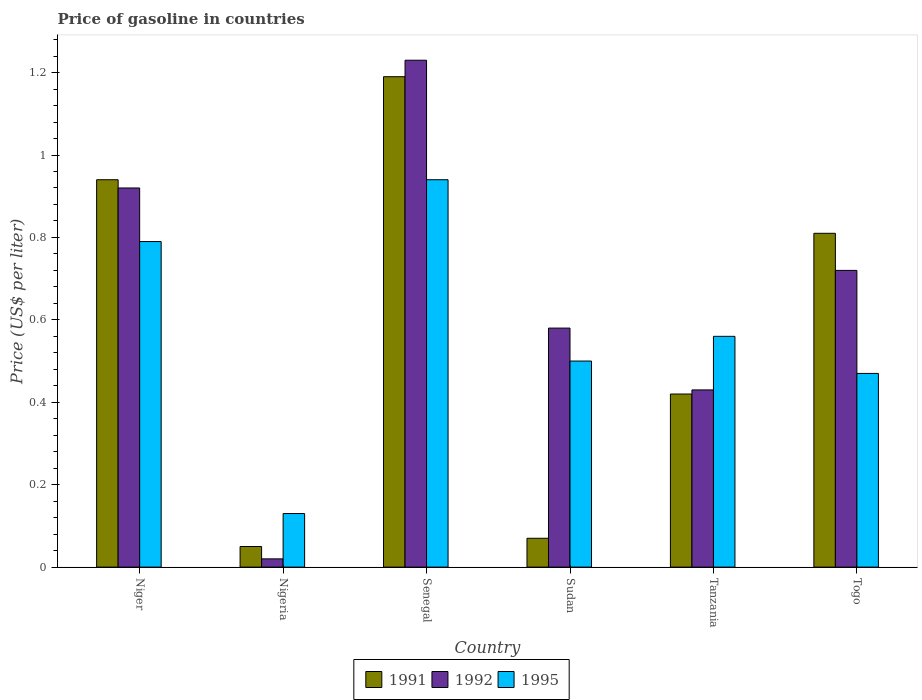How many different coloured bars are there?
Make the answer very short. 3. How many groups of bars are there?
Your response must be concise. 6. Are the number of bars per tick equal to the number of legend labels?
Make the answer very short. Yes. How many bars are there on the 2nd tick from the left?
Offer a very short reply. 3. How many bars are there on the 4th tick from the right?
Your response must be concise. 3. What is the label of the 4th group of bars from the left?
Your answer should be compact. Sudan. What is the price of gasoline in 1991 in Senegal?
Offer a very short reply. 1.19. Across all countries, what is the minimum price of gasoline in 1991?
Keep it short and to the point. 0.05. In which country was the price of gasoline in 1991 maximum?
Your response must be concise. Senegal. In which country was the price of gasoline in 1991 minimum?
Provide a short and direct response. Nigeria. What is the total price of gasoline in 1992 in the graph?
Offer a terse response. 3.9. What is the difference between the price of gasoline in 1995 in Niger and that in Tanzania?
Give a very brief answer. 0.23. What is the difference between the price of gasoline in 1992 in Tanzania and the price of gasoline in 1995 in Senegal?
Make the answer very short. -0.51. What is the average price of gasoline in 1992 per country?
Your answer should be very brief. 0.65. What is the difference between the price of gasoline of/in 1992 and price of gasoline of/in 1991 in Togo?
Give a very brief answer. -0.09. What is the ratio of the price of gasoline in 1991 in Nigeria to that in Sudan?
Make the answer very short. 0.71. What is the difference between the highest and the second highest price of gasoline in 1992?
Provide a succinct answer. -0.31. What is the difference between the highest and the lowest price of gasoline in 1992?
Ensure brevity in your answer.  1.21. In how many countries, is the price of gasoline in 1995 greater than the average price of gasoline in 1995 taken over all countries?
Keep it short and to the point. 2. What does the 3rd bar from the right in Nigeria represents?
Give a very brief answer. 1991. How many bars are there?
Your answer should be compact. 18. How many countries are there in the graph?
Give a very brief answer. 6. What is the difference between two consecutive major ticks on the Y-axis?
Provide a succinct answer. 0.2. Are the values on the major ticks of Y-axis written in scientific E-notation?
Ensure brevity in your answer.  No. What is the title of the graph?
Make the answer very short. Price of gasoline in countries. What is the label or title of the Y-axis?
Make the answer very short. Price (US$ per liter). What is the Price (US$ per liter) of 1991 in Niger?
Offer a very short reply. 0.94. What is the Price (US$ per liter) of 1992 in Niger?
Provide a short and direct response. 0.92. What is the Price (US$ per liter) of 1995 in Niger?
Keep it short and to the point. 0.79. What is the Price (US$ per liter) in 1991 in Nigeria?
Offer a terse response. 0.05. What is the Price (US$ per liter) of 1995 in Nigeria?
Ensure brevity in your answer.  0.13. What is the Price (US$ per liter) in 1991 in Senegal?
Your response must be concise. 1.19. What is the Price (US$ per liter) in 1992 in Senegal?
Your answer should be very brief. 1.23. What is the Price (US$ per liter) of 1995 in Senegal?
Your answer should be very brief. 0.94. What is the Price (US$ per liter) of 1991 in Sudan?
Keep it short and to the point. 0.07. What is the Price (US$ per liter) in 1992 in Sudan?
Offer a very short reply. 0.58. What is the Price (US$ per liter) in 1991 in Tanzania?
Provide a short and direct response. 0.42. What is the Price (US$ per liter) of 1992 in Tanzania?
Give a very brief answer. 0.43. What is the Price (US$ per liter) of 1995 in Tanzania?
Provide a succinct answer. 0.56. What is the Price (US$ per liter) in 1991 in Togo?
Your answer should be very brief. 0.81. What is the Price (US$ per liter) in 1992 in Togo?
Your response must be concise. 0.72. What is the Price (US$ per liter) of 1995 in Togo?
Your answer should be very brief. 0.47. Across all countries, what is the maximum Price (US$ per liter) of 1991?
Ensure brevity in your answer.  1.19. Across all countries, what is the maximum Price (US$ per liter) of 1992?
Your response must be concise. 1.23. Across all countries, what is the maximum Price (US$ per liter) in 1995?
Your response must be concise. 0.94. Across all countries, what is the minimum Price (US$ per liter) of 1991?
Ensure brevity in your answer.  0.05. Across all countries, what is the minimum Price (US$ per liter) in 1995?
Offer a terse response. 0.13. What is the total Price (US$ per liter) of 1991 in the graph?
Make the answer very short. 3.48. What is the total Price (US$ per liter) of 1992 in the graph?
Your answer should be compact. 3.9. What is the total Price (US$ per liter) in 1995 in the graph?
Offer a terse response. 3.39. What is the difference between the Price (US$ per liter) in 1991 in Niger and that in Nigeria?
Offer a very short reply. 0.89. What is the difference between the Price (US$ per liter) of 1992 in Niger and that in Nigeria?
Offer a terse response. 0.9. What is the difference between the Price (US$ per liter) of 1995 in Niger and that in Nigeria?
Make the answer very short. 0.66. What is the difference between the Price (US$ per liter) in 1992 in Niger and that in Senegal?
Provide a short and direct response. -0.31. What is the difference between the Price (US$ per liter) in 1995 in Niger and that in Senegal?
Give a very brief answer. -0.15. What is the difference between the Price (US$ per liter) in 1991 in Niger and that in Sudan?
Your answer should be compact. 0.87. What is the difference between the Price (US$ per liter) of 1992 in Niger and that in Sudan?
Provide a short and direct response. 0.34. What is the difference between the Price (US$ per liter) of 1995 in Niger and that in Sudan?
Your answer should be compact. 0.29. What is the difference between the Price (US$ per liter) of 1991 in Niger and that in Tanzania?
Your answer should be very brief. 0.52. What is the difference between the Price (US$ per liter) in 1992 in Niger and that in Tanzania?
Your answer should be compact. 0.49. What is the difference between the Price (US$ per liter) in 1995 in Niger and that in Tanzania?
Your answer should be very brief. 0.23. What is the difference between the Price (US$ per liter) in 1991 in Niger and that in Togo?
Offer a terse response. 0.13. What is the difference between the Price (US$ per liter) of 1992 in Niger and that in Togo?
Your response must be concise. 0.2. What is the difference between the Price (US$ per liter) of 1995 in Niger and that in Togo?
Make the answer very short. 0.32. What is the difference between the Price (US$ per liter) in 1991 in Nigeria and that in Senegal?
Offer a terse response. -1.14. What is the difference between the Price (US$ per liter) in 1992 in Nigeria and that in Senegal?
Keep it short and to the point. -1.21. What is the difference between the Price (US$ per liter) of 1995 in Nigeria and that in Senegal?
Provide a succinct answer. -0.81. What is the difference between the Price (US$ per liter) of 1991 in Nigeria and that in Sudan?
Your answer should be compact. -0.02. What is the difference between the Price (US$ per liter) in 1992 in Nigeria and that in Sudan?
Provide a succinct answer. -0.56. What is the difference between the Price (US$ per liter) of 1995 in Nigeria and that in Sudan?
Give a very brief answer. -0.37. What is the difference between the Price (US$ per liter) of 1991 in Nigeria and that in Tanzania?
Ensure brevity in your answer.  -0.37. What is the difference between the Price (US$ per liter) of 1992 in Nigeria and that in Tanzania?
Offer a terse response. -0.41. What is the difference between the Price (US$ per liter) of 1995 in Nigeria and that in Tanzania?
Keep it short and to the point. -0.43. What is the difference between the Price (US$ per liter) in 1991 in Nigeria and that in Togo?
Give a very brief answer. -0.76. What is the difference between the Price (US$ per liter) in 1992 in Nigeria and that in Togo?
Give a very brief answer. -0.7. What is the difference between the Price (US$ per liter) in 1995 in Nigeria and that in Togo?
Your answer should be compact. -0.34. What is the difference between the Price (US$ per liter) in 1991 in Senegal and that in Sudan?
Your response must be concise. 1.12. What is the difference between the Price (US$ per liter) of 1992 in Senegal and that in Sudan?
Provide a succinct answer. 0.65. What is the difference between the Price (US$ per liter) of 1995 in Senegal and that in Sudan?
Give a very brief answer. 0.44. What is the difference between the Price (US$ per liter) in 1991 in Senegal and that in Tanzania?
Your answer should be very brief. 0.77. What is the difference between the Price (US$ per liter) of 1995 in Senegal and that in Tanzania?
Provide a short and direct response. 0.38. What is the difference between the Price (US$ per liter) in 1991 in Senegal and that in Togo?
Keep it short and to the point. 0.38. What is the difference between the Price (US$ per liter) in 1992 in Senegal and that in Togo?
Your answer should be compact. 0.51. What is the difference between the Price (US$ per liter) in 1995 in Senegal and that in Togo?
Provide a short and direct response. 0.47. What is the difference between the Price (US$ per liter) of 1991 in Sudan and that in Tanzania?
Offer a terse response. -0.35. What is the difference between the Price (US$ per liter) of 1995 in Sudan and that in Tanzania?
Provide a succinct answer. -0.06. What is the difference between the Price (US$ per liter) of 1991 in Sudan and that in Togo?
Ensure brevity in your answer.  -0.74. What is the difference between the Price (US$ per liter) in 1992 in Sudan and that in Togo?
Make the answer very short. -0.14. What is the difference between the Price (US$ per liter) of 1991 in Tanzania and that in Togo?
Provide a succinct answer. -0.39. What is the difference between the Price (US$ per liter) of 1992 in Tanzania and that in Togo?
Give a very brief answer. -0.29. What is the difference between the Price (US$ per liter) of 1995 in Tanzania and that in Togo?
Give a very brief answer. 0.09. What is the difference between the Price (US$ per liter) of 1991 in Niger and the Price (US$ per liter) of 1995 in Nigeria?
Give a very brief answer. 0.81. What is the difference between the Price (US$ per liter) in 1992 in Niger and the Price (US$ per liter) in 1995 in Nigeria?
Offer a terse response. 0.79. What is the difference between the Price (US$ per liter) of 1991 in Niger and the Price (US$ per liter) of 1992 in Senegal?
Offer a terse response. -0.29. What is the difference between the Price (US$ per liter) in 1991 in Niger and the Price (US$ per liter) in 1995 in Senegal?
Make the answer very short. 0. What is the difference between the Price (US$ per liter) in 1992 in Niger and the Price (US$ per liter) in 1995 in Senegal?
Make the answer very short. -0.02. What is the difference between the Price (US$ per liter) of 1991 in Niger and the Price (US$ per liter) of 1992 in Sudan?
Offer a terse response. 0.36. What is the difference between the Price (US$ per liter) in 1991 in Niger and the Price (US$ per liter) in 1995 in Sudan?
Offer a terse response. 0.44. What is the difference between the Price (US$ per liter) of 1992 in Niger and the Price (US$ per liter) of 1995 in Sudan?
Give a very brief answer. 0.42. What is the difference between the Price (US$ per liter) of 1991 in Niger and the Price (US$ per liter) of 1992 in Tanzania?
Offer a terse response. 0.51. What is the difference between the Price (US$ per liter) in 1991 in Niger and the Price (US$ per liter) in 1995 in Tanzania?
Provide a short and direct response. 0.38. What is the difference between the Price (US$ per liter) of 1992 in Niger and the Price (US$ per liter) of 1995 in Tanzania?
Give a very brief answer. 0.36. What is the difference between the Price (US$ per liter) of 1991 in Niger and the Price (US$ per liter) of 1992 in Togo?
Your answer should be very brief. 0.22. What is the difference between the Price (US$ per liter) of 1991 in Niger and the Price (US$ per liter) of 1995 in Togo?
Your answer should be compact. 0.47. What is the difference between the Price (US$ per liter) of 1992 in Niger and the Price (US$ per liter) of 1995 in Togo?
Your answer should be compact. 0.45. What is the difference between the Price (US$ per liter) in 1991 in Nigeria and the Price (US$ per liter) in 1992 in Senegal?
Make the answer very short. -1.18. What is the difference between the Price (US$ per liter) of 1991 in Nigeria and the Price (US$ per liter) of 1995 in Senegal?
Your response must be concise. -0.89. What is the difference between the Price (US$ per liter) in 1992 in Nigeria and the Price (US$ per liter) in 1995 in Senegal?
Provide a succinct answer. -0.92. What is the difference between the Price (US$ per liter) in 1991 in Nigeria and the Price (US$ per liter) in 1992 in Sudan?
Keep it short and to the point. -0.53. What is the difference between the Price (US$ per liter) in 1991 in Nigeria and the Price (US$ per liter) in 1995 in Sudan?
Your answer should be compact. -0.45. What is the difference between the Price (US$ per liter) in 1992 in Nigeria and the Price (US$ per liter) in 1995 in Sudan?
Give a very brief answer. -0.48. What is the difference between the Price (US$ per liter) of 1991 in Nigeria and the Price (US$ per liter) of 1992 in Tanzania?
Your response must be concise. -0.38. What is the difference between the Price (US$ per liter) in 1991 in Nigeria and the Price (US$ per liter) in 1995 in Tanzania?
Ensure brevity in your answer.  -0.51. What is the difference between the Price (US$ per liter) in 1992 in Nigeria and the Price (US$ per liter) in 1995 in Tanzania?
Your answer should be compact. -0.54. What is the difference between the Price (US$ per liter) of 1991 in Nigeria and the Price (US$ per liter) of 1992 in Togo?
Make the answer very short. -0.67. What is the difference between the Price (US$ per liter) of 1991 in Nigeria and the Price (US$ per liter) of 1995 in Togo?
Provide a short and direct response. -0.42. What is the difference between the Price (US$ per liter) of 1992 in Nigeria and the Price (US$ per liter) of 1995 in Togo?
Provide a short and direct response. -0.45. What is the difference between the Price (US$ per liter) of 1991 in Senegal and the Price (US$ per liter) of 1992 in Sudan?
Give a very brief answer. 0.61. What is the difference between the Price (US$ per liter) of 1991 in Senegal and the Price (US$ per liter) of 1995 in Sudan?
Ensure brevity in your answer.  0.69. What is the difference between the Price (US$ per liter) of 1992 in Senegal and the Price (US$ per liter) of 1995 in Sudan?
Offer a terse response. 0.73. What is the difference between the Price (US$ per liter) in 1991 in Senegal and the Price (US$ per liter) in 1992 in Tanzania?
Provide a succinct answer. 0.76. What is the difference between the Price (US$ per liter) in 1991 in Senegal and the Price (US$ per liter) in 1995 in Tanzania?
Your response must be concise. 0.63. What is the difference between the Price (US$ per liter) in 1992 in Senegal and the Price (US$ per liter) in 1995 in Tanzania?
Your answer should be compact. 0.67. What is the difference between the Price (US$ per liter) in 1991 in Senegal and the Price (US$ per liter) in 1992 in Togo?
Provide a short and direct response. 0.47. What is the difference between the Price (US$ per liter) in 1991 in Senegal and the Price (US$ per liter) in 1995 in Togo?
Your answer should be very brief. 0.72. What is the difference between the Price (US$ per liter) in 1992 in Senegal and the Price (US$ per liter) in 1995 in Togo?
Offer a very short reply. 0.76. What is the difference between the Price (US$ per liter) in 1991 in Sudan and the Price (US$ per liter) in 1992 in Tanzania?
Offer a terse response. -0.36. What is the difference between the Price (US$ per liter) in 1991 in Sudan and the Price (US$ per liter) in 1995 in Tanzania?
Your answer should be very brief. -0.49. What is the difference between the Price (US$ per liter) of 1991 in Sudan and the Price (US$ per liter) of 1992 in Togo?
Offer a terse response. -0.65. What is the difference between the Price (US$ per liter) of 1991 in Sudan and the Price (US$ per liter) of 1995 in Togo?
Your response must be concise. -0.4. What is the difference between the Price (US$ per liter) in 1992 in Sudan and the Price (US$ per liter) in 1995 in Togo?
Give a very brief answer. 0.11. What is the difference between the Price (US$ per liter) of 1991 in Tanzania and the Price (US$ per liter) of 1992 in Togo?
Your answer should be compact. -0.3. What is the difference between the Price (US$ per liter) of 1991 in Tanzania and the Price (US$ per liter) of 1995 in Togo?
Ensure brevity in your answer.  -0.05. What is the difference between the Price (US$ per liter) in 1992 in Tanzania and the Price (US$ per liter) in 1995 in Togo?
Provide a succinct answer. -0.04. What is the average Price (US$ per liter) of 1991 per country?
Your answer should be compact. 0.58. What is the average Price (US$ per liter) in 1992 per country?
Provide a succinct answer. 0.65. What is the average Price (US$ per liter) of 1995 per country?
Provide a succinct answer. 0.56. What is the difference between the Price (US$ per liter) in 1991 and Price (US$ per liter) in 1995 in Niger?
Your answer should be compact. 0.15. What is the difference between the Price (US$ per liter) of 1992 and Price (US$ per liter) of 1995 in Niger?
Provide a short and direct response. 0.13. What is the difference between the Price (US$ per liter) in 1991 and Price (US$ per liter) in 1992 in Nigeria?
Your answer should be compact. 0.03. What is the difference between the Price (US$ per liter) in 1991 and Price (US$ per liter) in 1995 in Nigeria?
Your answer should be compact. -0.08. What is the difference between the Price (US$ per liter) of 1992 and Price (US$ per liter) of 1995 in Nigeria?
Make the answer very short. -0.11. What is the difference between the Price (US$ per liter) in 1991 and Price (US$ per liter) in 1992 in Senegal?
Give a very brief answer. -0.04. What is the difference between the Price (US$ per liter) in 1992 and Price (US$ per liter) in 1995 in Senegal?
Provide a succinct answer. 0.29. What is the difference between the Price (US$ per liter) in 1991 and Price (US$ per liter) in 1992 in Sudan?
Provide a succinct answer. -0.51. What is the difference between the Price (US$ per liter) in 1991 and Price (US$ per liter) in 1995 in Sudan?
Make the answer very short. -0.43. What is the difference between the Price (US$ per liter) in 1992 and Price (US$ per liter) in 1995 in Sudan?
Your answer should be very brief. 0.08. What is the difference between the Price (US$ per liter) of 1991 and Price (US$ per liter) of 1992 in Tanzania?
Your response must be concise. -0.01. What is the difference between the Price (US$ per liter) of 1991 and Price (US$ per liter) of 1995 in Tanzania?
Offer a very short reply. -0.14. What is the difference between the Price (US$ per liter) of 1992 and Price (US$ per liter) of 1995 in Tanzania?
Provide a short and direct response. -0.13. What is the difference between the Price (US$ per liter) of 1991 and Price (US$ per liter) of 1992 in Togo?
Offer a very short reply. 0.09. What is the difference between the Price (US$ per liter) of 1991 and Price (US$ per liter) of 1995 in Togo?
Offer a very short reply. 0.34. What is the difference between the Price (US$ per liter) of 1992 and Price (US$ per liter) of 1995 in Togo?
Your response must be concise. 0.25. What is the ratio of the Price (US$ per liter) in 1992 in Niger to that in Nigeria?
Provide a succinct answer. 46. What is the ratio of the Price (US$ per liter) of 1995 in Niger to that in Nigeria?
Provide a succinct answer. 6.08. What is the ratio of the Price (US$ per liter) of 1991 in Niger to that in Senegal?
Give a very brief answer. 0.79. What is the ratio of the Price (US$ per liter) of 1992 in Niger to that in Senegal?
Ensure brevity in your answer.  0.75. What is the ratio of the Price (US$ per liter) of 1995 in Niger to that in Senegal?
Your response must be concise. 0.84. What is the ratio of the Price (US$ per liter) of 1991 in Niger to that in Sudan?
Your answer should be compact. 13.43. What is the ratio of the Price (US$ per liter) of 1992 in Niger to that in Sudan?
Give a very brief answer. 1.59. What is the ratio of the Price (US$ per liter) in 1995 in Niger to that in Sudan?
Provide a short and direct response. 1.58. What is the ratio of the Price (US$ per liter) of 1991 in Niger to that in Tanzania?
Provide a short and direct response. 2.24. What is the ratio of the Price (US$ per liter) of 1992 in Niger to that in Tanzania?
Ensure brevity in your answer.  2.14. What is the ratio of the Price (US$ per liter) in 1995 in Niger to that in Tanzania?
Ensure brevity in your answer.  1.41. What is the ratio of the Price (US$ per liter) of 1991 in Niger to that in Togo?
Ensure brevity in your answer.  1.16. What is the ratio of the Price (US$ per liter) of 1992 in Niger to that in Togo?
Ensure brevity in your answer.  1.28. What is the ratio of the Price (US$ per liter) of 1995 in Niger to that in Togo?
Give a very brief answer. 1.68. What is the ratio of the Price (US$ per liter) in 1991 in Nigeria to that in Senegal?
Keep it short and to the point. 0.04. What is the ratio of the Price (US$ per liter) of 1992 in Nigeria to that in Senegal?
Give a very brief answer. 0.02. What is the ratio of the Price (US$ per liter) in 1995 in Nigeria to that in Senegal?
Offer a terse response. 0.14. What is the ratio of the Price (US$ per liter) of 1992 in Nigeria to that in Sudan?
Give a very brief answer. 0.03. What is the ratio of the Price (US$ per liter) in 1995 in Nigeria to that in Sudan?
Offer a terse response. 0.26. What is the ratio of the Price (US$ per liter) of 1991 in Nigeria to that in Tanzania?
Give a very brief answer. 0.12. What is the ratio of the Price (US$ per liter) in 1992 in Nigeria to that in Tanzania?
Give a very brief answer. 0.05. What is the ratio of the Price (US$ per liter) in 1995 in Nigeria to that in Tanzania?
Provide a succinct answer. 0.23. What is the ratio of the Price (US$ per liter) in 1991 in Nigeria to that in Togo?
Keep it short and to the point. 0.06. What is the ratio of the Price (US$ per liter) in 1992 in Nigeria to that in Togo?
Make the answer very short. 0.03. What is the ratio of the Price (US$ per liter) of 1995 in Nigeria to that in Togo?
Your answer should be compact. 0.28. What is the ratio of the Price (US$ per liter) of 1991 in Senegal to that in Sudan?
Offer a very short reply. 17. What is the ratio of the Price (US$ per liter) of 1992 in Senegal to that in Sudan?
Offer a terse response. 2.12. What is the ratio of the Price (US$ per liter) of 1995 in Senegal to that in Sudan?
Your response must be concise. 1.88. What is the ratio of the Price (US$ per liter) in 1991 in Senegal to that in Tanzania?
Offer a very short reply. 2.83. What is the ratio of the Price (US$ per liter) of 1992 in Senegal to that in Tanzania?
Provide a short and direct response. 2.86. What is the ratio of the Price (US$ per liter) of 1995 in Senegal to that in Tanzania?
Keep it short and to the point. 1.68. What is the ratio of the Price (US$ per liter) of 1991 in Senegal to that in Togo?
Provide a short and direct response. 1.47. What is the ratio of the Price (US$ per liter) of 1992 in Senegal to that in Togo?
Give a very brief answer. 1.71. What is the ratio of the Price (US$ per liter) of 1992 in Sudan to that in Tanzania?
Your answer should be compact. 1.35. What is the ratio of the Price (US$ per liter) of 1995 in Sudan to that in Tanzania?
Give a very brief answer. 0.89. What is the ratio of the Price (US$ per liter) in 1991 in Sudan to that in Togo?
Your answer should be very brief. 0.09. What is the ratio of the Price (US$ per liter) in 1992 in Sudan to that in Togo?
Offer a terse response. 0.81. What is the ratio of the Price (US$ per liter) of 1995 in Sudan to that in Togo?
Offer a terse response. 1.06. What is the ratio of the Price (US$ per liter) in 1991 in Tanzania to that in Togo?
Ensure brevity in your answer.  0.52. What is the ratio of the Price (US$ per liter) of 1992 in Tanzania to that in Togo?
Offer a terse response. 0.6. What is the ratio of the Price (US$ per liter) in 1995 in Tanzania to that in Togo?
Provide a short and direct response. 1.19. What is the difference between the highest and the second highest Price (US$ per liter) of 1991?
Your answer should be compact. 0.25. What is the difference between the highest and the second highest Price (US$ per liter) of 1992?
Provide a succinct answer. 0.31. What is the difference between the highest and the lowest Price (US$ per liter) of 1991?
Make the answer very short. 1.14. What is the difference between the highest and the lowest Price (US$ per liter) in 1992?
Provide a succinct answer. 1.21. What is the difference between the highest and the lowest Price (US$ per liter) in 1995?
Give a very brief answer. 0.81. 